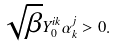<formula> <loc_0><loc_0><loc_500><loc_500>\sqrt { \beta } Y _ { 0 } ^ { i k } \alpha _ { k } ^ { j } > 0 .</formula> 